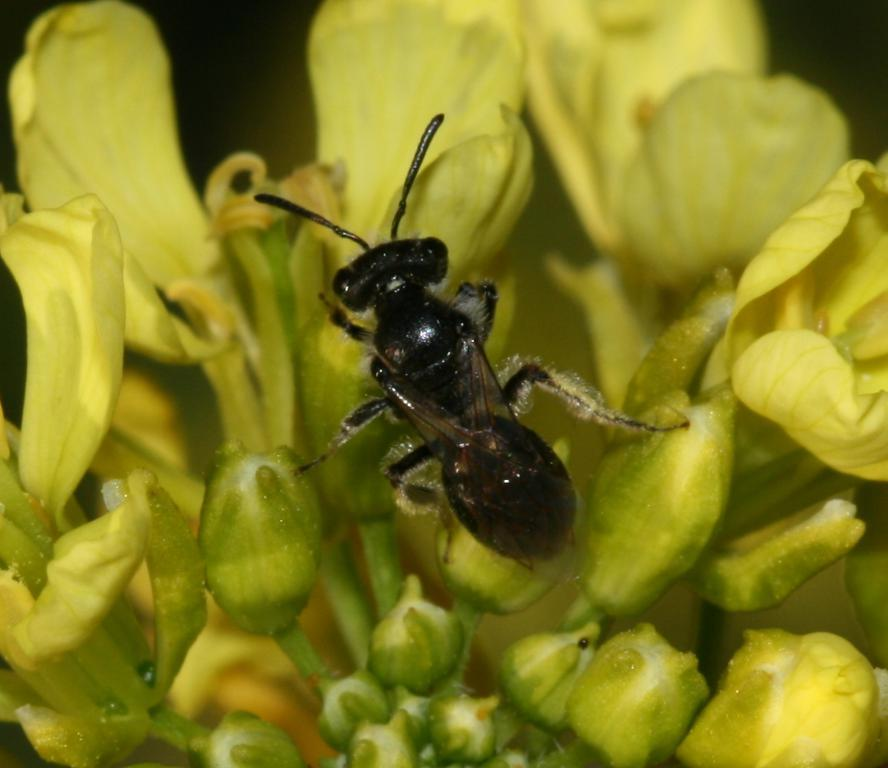What is on the flowers in the image? There is an insect on the flowers in the image. How are the flowers attached to the stem? The flowers are on a stem in the image. What is the growth stage of some of the flowers on the stem? There are buds on the stem in the image. Can you describe the background of the image? The background of the image is blurry. How much money is being exchanged between the insect and the flowers in the image? There is no money being exchanged in the image; it features an insect on the flowers. What type of system is being used to maintain the flowers in the image? There is no system mentioned or visible in the image; it simply shows an insect on the flowers. 